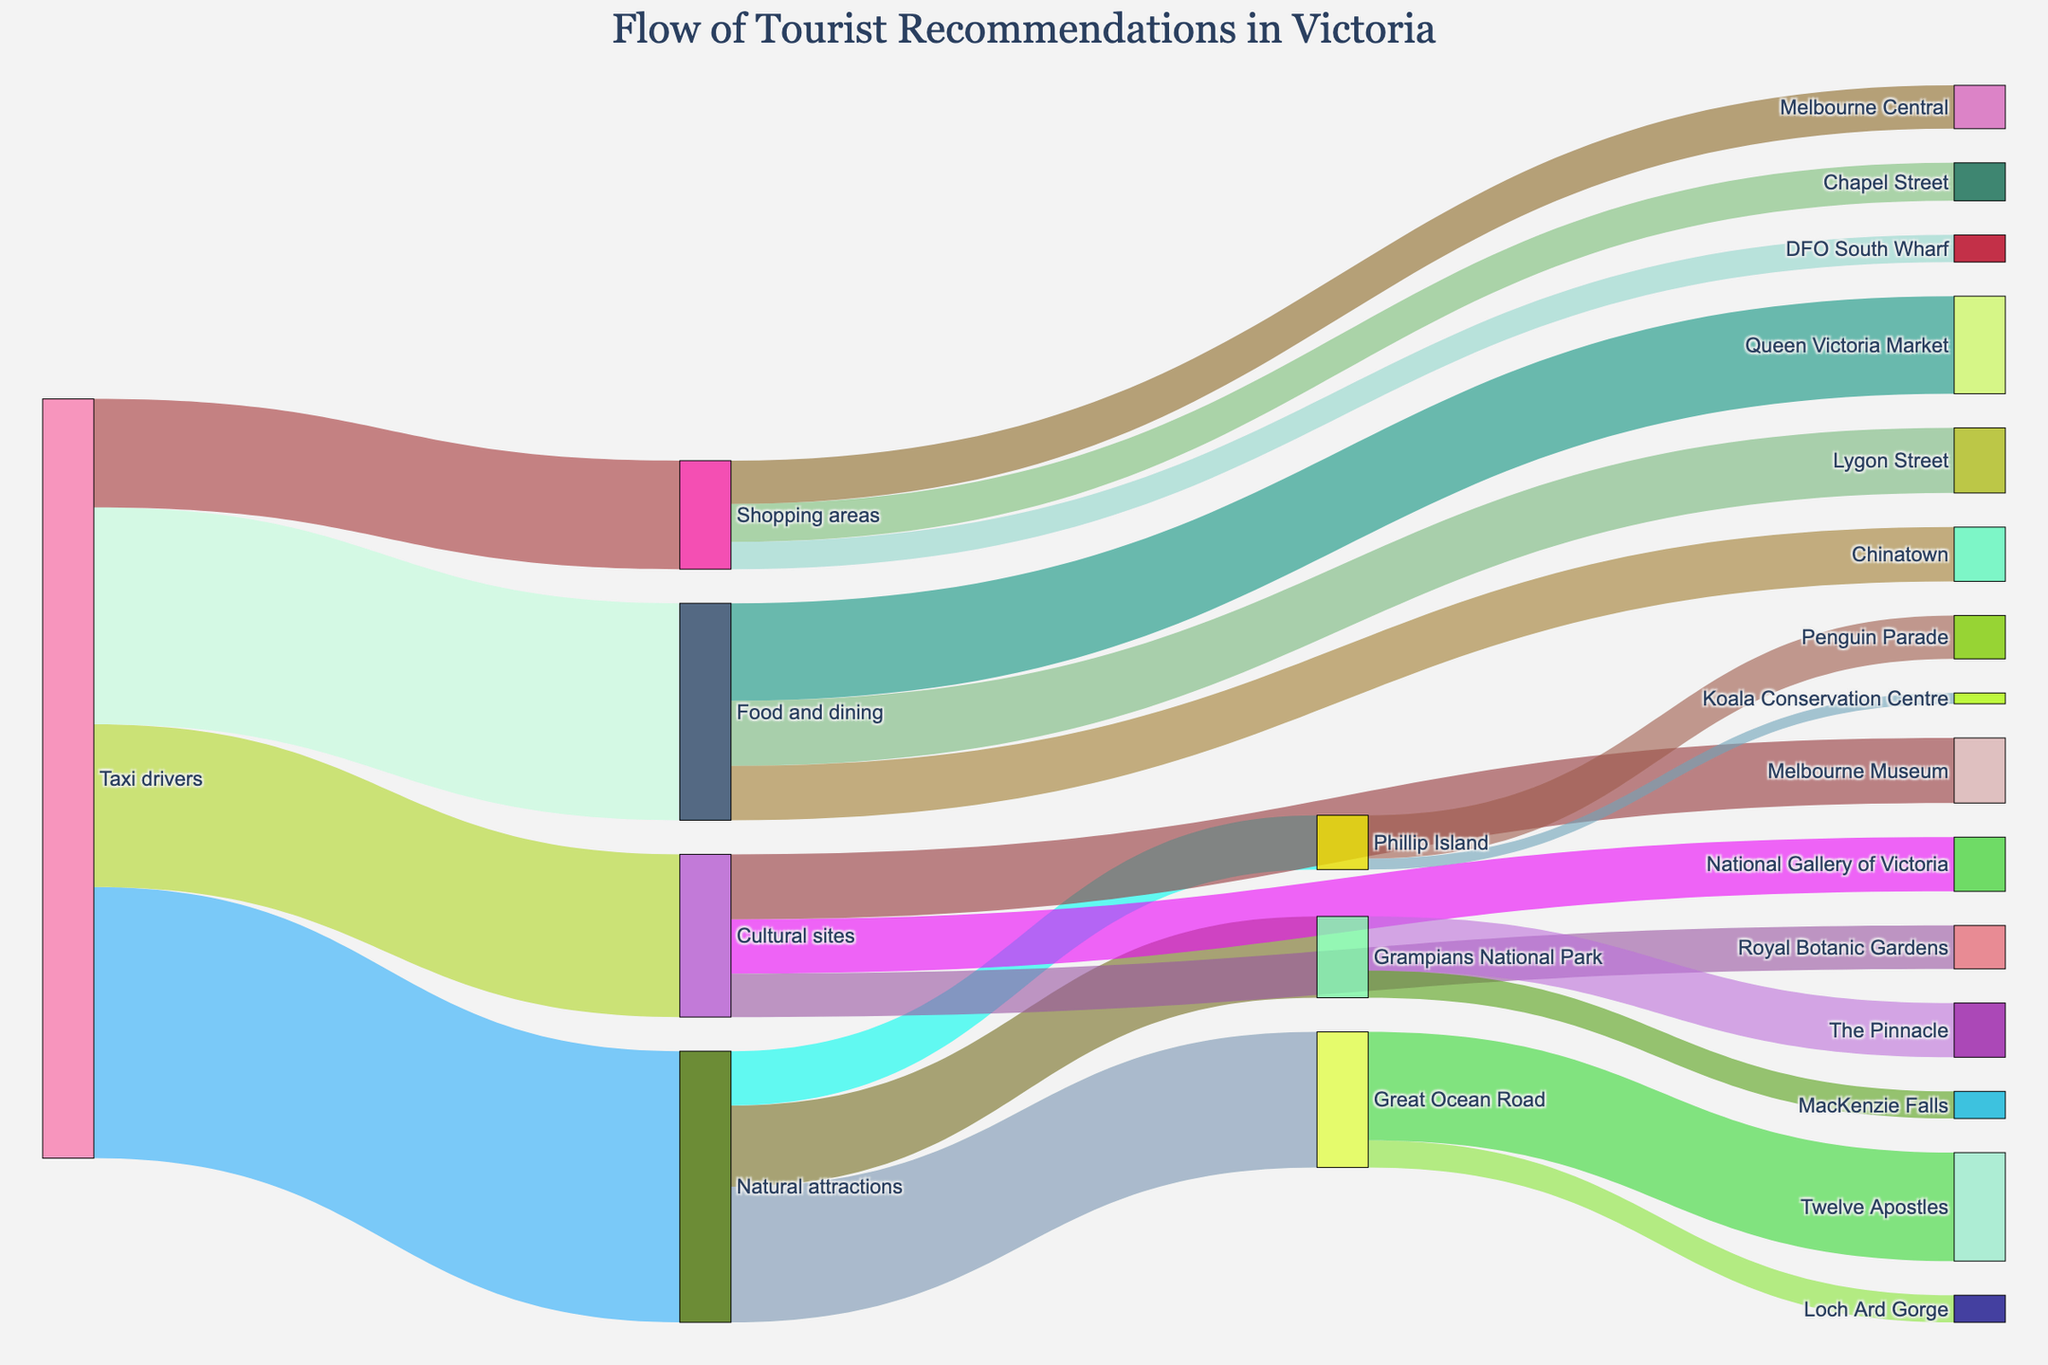What is the title of the diagram? The title can be found at the top of the diagram. It reads "Flow of Tourist Recommendations in Victoria".
Answer: Flow of Tourist Recommendations in Victoria How many tourists were recommended to visit the Natural attractions? Look at the flow from "Taxi drivers" to "Natural attractions" which shows the number of tourists. The value is 500.
Answer: 500 Which specific attraction under Natural attractions has the highest number of visitors? Look at the sub-flows from "Natural attractions" to individual destinations. The highest value among them is "Great Ocean Road" with 250 visitors.
Answer: Great Ocean Road How many tourists visited the Twelve Apostles? Follow the flow from "Great Ocean Road" to its sub-categories. The "Twelve Apostles" received 200 visitors.
Answer: 200 What is the total number of tourists recommended to Shopping areas and their specific attractions? Sum the values feeding into "Shopping areas" and each of its sub-categories: 200 (Shopping areas) = 80 (Melbourne Central) + 70 (Chapel Street) + 50 (DFO South Wharf).
Answer: 200 Which attraction received more visitors, Melbourne Museum or Penguin Parade? Compare the values from "Cultural sites" to "Melbourne Museum" (120) and "Phillip Island" to "Penguin Parade" (80). Melbourne Museum has more visitors.
Answer: Melbourne Museum From the Shopping Areas, how many fewer visitors went to DFO South Wharf compared to Melbourne Central? Subtract the visitors of "DFO South Wharf" (50) from "Melbourne Central" (80): 80 - 50 = 30.
Answer: 30 How does the number of visitors to Lygon Street compare to Chinatown? Compare the values from "Food and dining" to "Lygon Street" (120) and "Chinatown" (100). Lygon Street has more visitors.
Answer: Lygon Street What is the total number of visitors to Cultural sites and their specific attractions? Add the values of all sub-categories under "Cultural sites": 120 (Melbourne Museum) + 100 (National Gallery of Victoria) + 80 (Royal Botanic Gardens) = 300.
Answer: 300 Which specific attraction under Grampians National Park has more visitors? Look at the flow from "Grampians National Park" to its sub-categories. "The Pinnacle" has 100 visitors whereas "MacKenzie Falls" has 50.
Answer: The Pinnacle 